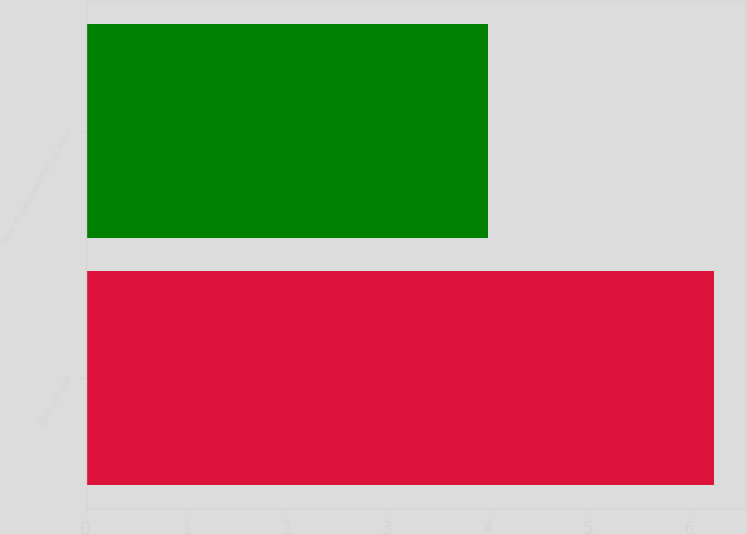<chart> <loc_0><loc_0><loc_500><loc_500><bar_chart><fcel>Discount rate<fcel>Rate of compensation increase<nl><fcel>6.25<fcel>4<nl></chart> 